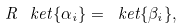<formula> <loc_0><loc_0><loc_500><loc_500>R \, \ k e t { \{ \alpha _ { i } \} } = \ k e t { \{ \beta _ { i } \} } ,</formula> 